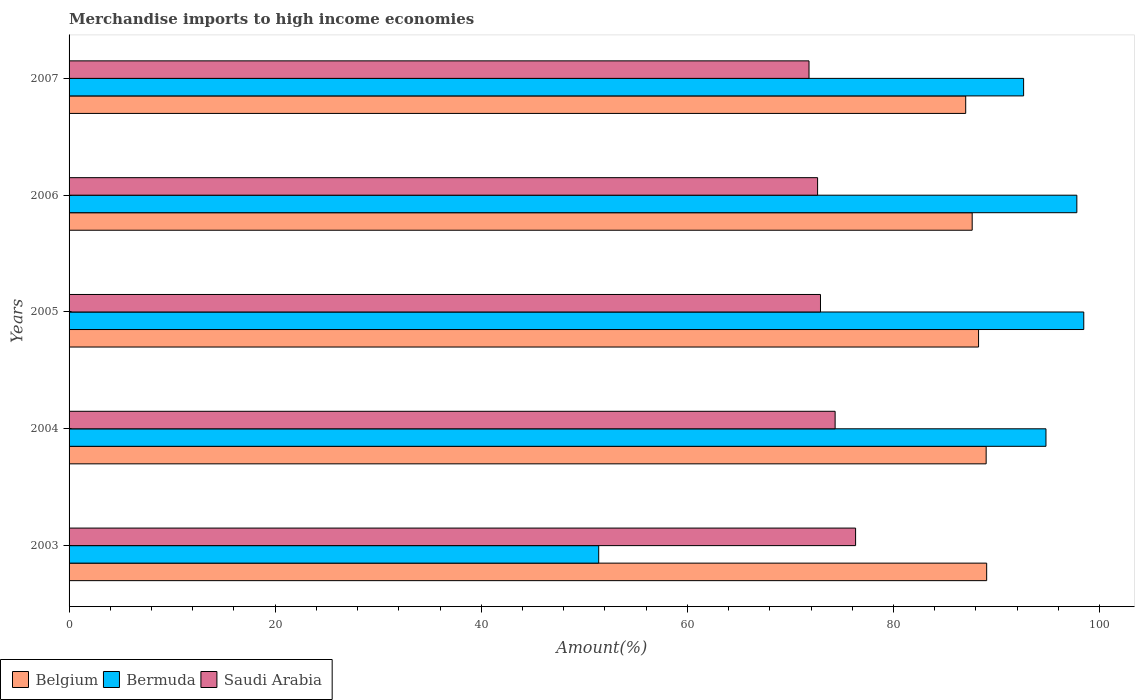How many groups of bars are there?
Provide a short and direct response. 5. Are the number of bars on each tick of the Y-axis equal?
Give a very brief answer. Yes. What is the label of the 1st group of bars from the top?
Your answer should be compact. 2007. In how many cases, is the number of bars for a given year not equal to the number of legend labels?
Make the answer very short. 0. What is the percentage of amount earned from merchandise imports in Saudi Arabia in 2005?
Ensure brevity in your answer.  72.91. Across all years, what is the maximum percentage of amount earned from merchandise imports in Saudi Arabia?
Make the answer very short. 76.32. Across all years, what is the minimum percentage of amount earned from merchandise imports in Saudi Arabia?
Offer a terse response. 71.8. In which year was the percentage of amount earned from merchandise imports in Belgium minimum?
Keep it short and to the point. 2007. What is the total percentage of amount earned from merchandise imports in Belgium in the graph?
Your answer should be compact. 440.92. What is the difference between the percentage of amount earned from merchandise imports in Saudi Arabia in 2005 and that in 2007?
Provide a succinct answer. 1.11. What is the difference between the percentage of amount earned from merchandise imports in Bermuda in 2004 and the percentage of amount earned from merchandise imports in Saudi Arabia in 2003?
Keep it short and to the point. 18.47. What is the average percentage of amount earned from merchandise imports in Belgium per year?
Offer a terse response. 88.18. In the year 2006, what is the difference between the percentage of amount earned from merchandise imports in Bermuda and percentage of amount earned from merchandise imports in Saudi Arabia?
Make the answer very short. 25.16. In how many years, is the percentage of amount earned from merchandise imports in Belgium greater than 48 %?
Your answer should be very brief. 5. What is the ratio of the percentage of amount earned from merchandise imports in Belgium in 2003 to that in 2004?
Provide a succinct answer. 1. Is the percentage of amount earned from merchandise imports in Belgium in 2005 less than that in 2006?
Provide a short and direct response. No. Is the difference between the percentage of amount earned from merchandise imports in Bermuda in 2003 and 2007 greater than the difference between the percentage of amount earned from merchandise imports in Saudi Arabia in 2003 and 2007?
Offer a very short reply. No. What is the difference between the highest and the second highest percentage of amount earned from merchandise imports in Belgium?
Ensure brevity in your answer.  0.05. What is the difference between the highest and the lowest percentage of amount earned from merchandise imports in Saudi Arabia?
Your answer should be compact. 4.52. In how many years, is the percentage of amount earned from merchandise imports in Bermuda greater than the average percentage of amount earned from merchandise imports in Bermuda taken over all years?
Provide a succinct answer. 4. Is the sum of the percentage of amount earned from merchandise imports in Bermuda in 2003 and 2005 greater than the maximum percentage of amount earned from merchandise imports in Belgium across all years?
Give a very brief answer. Yes. What does the 2nd bar from the top in 2006 represents?
Ensure brevity in your answer.  Bermuda. What does the 2nd bar from the bottom in 2003 represents?
Ensure brevity in your answer.  Bermuda. Are all the bars in the graph horizontal?
Offer a terse response. Yes. What is the difference between two consecutive major ticks on the X-axis?
Your response must be concise. 20. Are the values on the major ticks of X-axis written in scientific E-notation?
Provide a succinct answer. No. Where does the legend appear in the graph?
Ensure brevity in your answer.  Bottom left. How are the legend labels stacked?
Your response must be concise. Horizontal. What is the title of the graph?
Offer a terse response. Merchandise imports to high income economies. What is the label or title of the X-axis?
Offer a very short reply. Amount(%). What is the label or title of the Y-axis?
Offer a very short reply. Years. What is the Amount(%) in Belgium in 2003?
Give a very brief answer. 89.04. What is the Amount(%) of Bermuda in 2003?
Ensure brevity in your answer.  51.39. What is the Amount(%) in Saudi Arabia in 2003?
Your answer should be compact. 76.32. What is the Amount(%) in Belgium in 2004?
Provide a short and direct response. 88.99. What is the Amount(%) of Bermuda in 2004?
Offer a terse response. 94.79. What is the Amount(%) of Saudi Arabia in 2004?
Give a very brief answer. 74.33. What is the Amount(%) of Belgium in 2005?
Your response must be concise. 88.25. What is the Amount(%) in Bermuda in 2005?
Your answer should be very brief. 98.46. What is the Amount(%) in Saudi Arabia in 2005?
Ensure brevity in your answer.  72.91. What is the Amount(%) of Belgium in 2006?
Your answer should be compact. 87.63. What is the Amount(%) of Bermuda in 2006?
Ensure brevity in your answer.  97.79. What is the Amount(%) of Saudi Arabia in 2006?
Your answer should be very brief. 72.63. What is the Amount(%) of Belgium in 2007?
Make the answer very short. 87. What is the Amount(%) in Bermuda in 2007?
Your answer should be very brief. 92.62. What is the Amount(%) of Saudi Arabia in 2007?
Make the answer very short. 71.8. Across all years, what is the maximum Amount(%) of Belgium?
Provide a succinct answer. 89.04. Across all years, what is the maximum Amount(%) of Bermuda?
Offer a terse response. 98.46. Across all years, what is the maximum Amount(%) in Saudi Arabia?
Keep it short and to the point. 76.32. Across all years, what is the minimum Amount(%) of Belgium?
Ensure brevity in your answer.  87. Across all years, what is the minimum Amount(%) of Bermuda?
Ensure brevity in your answer.  51.39. Across all years, what is the minimum Amount(%) in Saudi Arabia?
Ensure brevity in your answer.  71.8. What is the total Amount(%) in Belgium in the graph?
Your response must be concise. 440.92. What is the total Amount(%) in Bermuda in the graph?
Keep it short and to the point. 435.05. What is the total Amount(%) in Saudi Arabia in the graph?
Make the answer very short. 368. What is the difference between the Amount(%) in Belgium in 2003 and that in 2004?
Your answer should be compact. 0.05. What is the difference between the Amount(%) in Bermuda in 2003 and that in 2004?
Keep it short and to the point. -43.4. What is the difference between the Amount(%) of Saudi Arabia in 2003 and that in 2004?
Your answer should be compact. 1.99. What is the difference between the Amount(%) of Belgium in 2003 and that in 2005?
Make the answer very short. 0.79. What is the difference between the Amount(%) of Bermuda in 2003 and that in 2005?
Your answer should be very brief. -47.07. What is the difference between the Amount(%) of Saudi Arabia in 2003 and that in 2005?
Your answer should be compact. 3.41. What is the difference between the Amount(%) in Belgium in 2003 and that in 2006?
Your response must be concise. 1.41. What is the difference between the Amount(%) of Bermuda in 2003 and that in 2006?
Give a very brief answer. -46.4. What is the difference between the Amount(%) in Saudi Arabia in 2003 and that in 2006?
Give a very brief answer. 3.69. What is the difference between the Amount(%) of Belgium in 2003 and that in 2007?
Give a very brief answer. 2.03. What is the difference between the Amount(%) in Bermuda in 2003 and that in 2007?
Ensure brevity in your answer.  -41.23. What is the difference between the Amount(%) in Saudi Arabia in 2003 and that in 2007?
Make the answer very short. 4.52. What is the difference between the Amount(%) of Belgium in 2004 and that in 2005?
Ensure brevity in your answer.  0.74. What is the difference between the Amount(%) in Bermuda in 2004 and that in 2005?
Make the answer very short. -3.67. What is the difference between the Amount(%) of Saudi Arabia in 2004 and that in 2005?
Make the answer very short. 1.42. What is the difference between the Amount(%) in Belgium in 2004 and that in 2006?
Your answer should be compact. 1.36. What is the difference between the Amount(%) in Bermuda in 2004 and that in 2006?
Your answer should be compact. -3. What is the difference between the Amount(%) in Saudi Arabia in 2004 and that in 2006?
Give a very brief answer. 1.7. What is the difference between the Amount(%) in Belgium in 2004 and that in 2007?
Give a very brief answer. 1.98. What is the difference between the Amount(%) of Bermuda in 2004 and that in 2007?
Provide a succinct answer. 2.17. What is the difference between the Amount(%) of Saudi Arabia in 2004 and that in 2007?
Offer a very short reply. 2.53. What is the difference between the Amount(%) in Belgium in 2005 and that in 2006?
Provide a short and direct response. 0.62. What is the difference between the Amount(%) of Bermuda in 2005 and that in 2006?
Offer a terse response. 0.67. What is the difference between the Amount(%) in Saudi Arabia in 2005 and that in 2006?
Your response must be concise. 0.28. What is the difference between the Amount(%) of Belgium in 2005 and that in 2007?
Provide a succinct answer. 1.25. What is the difference between the Amount(%) of Bermuda in 2005 and that in 2007?
Keep it short and to the point. 5.84. What is the difference between the Amount(%) of Saudi Arabia in 2005 and that in 2007?
Provide a short and direct response. 1.11. What is the difference between the Amount(%) in Belgium in 2006 and that in 2007?
Provide a succinct answer. 0.63. What is the difference between the Amount(%) of Bermuda in 2006 and that in 2007?
Your answer should be compact. 5.17. What is the difference between the Amount(%) of Saudi Arabia in 2006 and that in 2007?
Make the answer very short. 0.83. What is the difference between the Amount(%) in Belgium in 2003 and the Amount(%) in Bermuda in 2004?
Your answer should be very brief. -5.75. What is the difference between the Amount(%) of Belgium in 2003 and the Amount(%) of Saudi Arabia in 2004?
Ensure brevity in your answer.  14.7. What is the difference between the Amount(%) of Bermuda in 2003 and the Amount(%) of Saudi Arabia in 2004?
Offer a terse response. -22.94. What is the difference between the Amount(%) of Belgium in 2003 and the Amount(%) of Bermuda in 2005?
Provide a succinct answer. -9.42. What is the difference between the Amount(%) in Belgium in 2003 and the Amount(%) in Saudi Arabia in 2005?
Give a very brief answer. 16.13. What is the difference between the Amount(%) in Bermuda in 2003 and the Amount(%) in Saudi Arabia in 2005?
Your answer should be compact. -21.52. What is the difference between the Amount(%) of Belgium in 2003 and the Amount(%) of Bermuda in 2006?
Your answer should be very brief. -8.75. What is the difference between the Amount(%) in Belgium in 2003 and the Amount(%) in Saudi Arabia in 2006?
Offer a terse response. 16.41. What is the difference between the Amount(%) in Bermuda in 2003 and the Amount(%) in Saudi Arabia in 2006?
Provide a short and direct response. -21.24. What is the difference between the Amount(%) of Belgium in 2003 and the Amount(%) of Bermuda in 2007?
Your answer should be very brief. -3.58. What is the difference between the Amount(%) of Belgium in 2003 and the Amount(%) of Saudi Arabia in 2007?
Ensure brevity in your answer.  17.24. What is the difference between the Amount(%) of Bermuda in 2003 and the Amount(%) of Saudi Arabia in 2007?
Provide a succinct answer. -20.41. What is the difference between the Amount(%) of Belgium in 2004 and the Amount(%) of Bermuda in 2005?
Offer a terse response. -9.47. What is the difference between the Amount(%) of Belgium in 2004 and the Amount(%) of Saudi Arabia in 2005?
Give a very brief answer. 16.08. What is the difference between the Amount(%) of Bermuda in 2004 and the Amount(%) of Saudi Arabia in 2005?
Provide a succinct answer. 21.88. What is the difference between the Amount(%) in Belgium in 2004 and the Amount(%) in Bermuda in 2006?
Make the answer very short. -8.8. What is the difference between the Amount(%) in Belgium in 2004 and the Amount(%) in Saudi Arabia in 2006?
Your answer should be compact. 16.36. What is the difference between the Amount(%) of Bermuda in 2004 and the Amount(%) of Saudi Arabia in 2006?
Provide a short and direct response. 22.16. What is the difference between the Amount(%) in Belgium in 2004 and the Amount(%) in Bermuda in 2007?
Make the answer very short. -3.63. What is the difference between the Amount(%) of Belgium in 2004 and the Amount(%) of Saudi Arabia in 2007?
Keep it short and to the point. 17.19. What is the difference between the Amount(%) in Bermuda in 2004 and the Amount(%) in Saudi Arabia in 2007?
Provide a short and direct response. 22.99. What is the difference between the Amount(%) in Belgium in 2005 and the Amount(%) in Bermuda in 2006?
Keep it short and to the point. -9.54. What is the difference between the Amount(%) of Belgium in 2005 and the Amount(%) of Saudi Arabia in 2006?
Give a very brief answer. 15.62. What is the difference between the Amount(%) of Bermuda in 2005 and the Amount(%) of Saudi Arabia in 2006?
Offer a very short reply. 25.83. What is the difference between the Amount(%) of Belgium in 2005 and the Amount(%) of Bermuda in 2007?
Your answer should be very brief. -4.37. What is the difference between the Amount(%) of Belgium in 2005 and the Amount(%) of Saudi Arabia in 2007?
Ensure brevity in your answer.  16.45. What is the difference between the Amount(%) in Bermuda in 2005 and the Amount(%) in Saudi Arabia in 2007?
Ensure brevity in your answer.  26.66. What is the difference between the Amount(%) in Belgium in 2006 and the Amount(%) in Bermuda in 2007?
Keep it short and to the point. -4.99. What is the difference between the Amount(%) in Belgium in 2006 and the Amount(%) in Saudi Arabia in 2007?
Offer a very short reply. 15.83. What is the difference between the Amount(%) in Bermuda in 2006 and the Amount(%) in Saudi Arabia in 2007?
Ensure brevity in your answer.  25.99. What is the average Amount(%) in Belgium per year?
Provide a short and direct response. 88.18. What is the average Amount(%) in Bermuda per year?
Keep it short and to the point. 87.01. What is the average Amount(%) of Saudi Arabia per year?
Provide a succinct answer. 73.6. In the year 2003, what is the difference between the Amount(%) in Belgium and Amount(%) in Bermuda?
Give a very brief answer. 37.65. In the year 2003, what is the difference between the Amount(%) in Belgium and Amount(%) in Saudi Arabia?
Your answer should be compact. 12.72. In the year 2003, what is the difference between the Amount(%) of Bermuda and Amount(%) of Saudi Arabia?
Give a very brief answer. -24.93. In the year 2004, what is the difference between the Amount(%) in Belgium and Amount(%) in Bermuda?
Provide a succinct answer. -5.8. In the year 2004, what is the difference between the Amount(%) of Belgium and Amount(%) of Saudi Arabia?
Give a very brief answer. 14.66. In the year 2004, what is the difference between the Amount(%) in Bermuda and Amount(%) in Saudi Arabia?
Provide a short and direct response. 20.46. In the year 2005, what is the difference between the Amount(%) in Belgium and Amount(%) in Bermuda?
Offer a very short reply. -10.21. In the year 2005, what is the difference between the Amount(%) in Belgium and Amount(%) in Saudi Arabia?
Your answer should be compact. 15.34. In the year 2005, what is the difference between the Amount(%) in Bermuda and Amount(%) in Saudi Arabia?
Provide a short and direct response. 25.55. In the year 2006, what is the difference between the Amount(%) in Belgium and Amount(%) in Bermuda?
Provide a succinct answer. -10.15. In the year 2006, what is the difference between the Amount(%) in Belgium and Amount(%) in Saudi Arabia?
Make the answer very short. 15. In the year 2006, what is the difference between the Amount(%) of Bermuda and Amount(%) of Saudi Arabia?
Your response must be concise. 25.16. In the year 2007, what is the difference between the Amount(%) in Belgium and Amount(%) in Bermuda?
Your answer should be very brief. -5.62. In the year 2007, what is the difference between the Amount(%) in Belgium and Amount(%) in Saudi Arabia?
Ensure brevity in your answer.  15.2. In the year 2007, what is the difference between the Amount(%) in Bermuda and Amount(%) in Saudi Arabia?
Offer a very short reply. 20.82. What is the ratio of the Amount(%) in Bermuda in 2003 to that in 2004?
Offer a terse response. 0.54. What is the ratio of the Amount(%) of Saudi Arabia in 2003 to that in 2004?
Give a very brief answer. 1.03. What is the ratio of the Amount(%) of Belgium in 2003 to that in 2005?
Make the answer very short. 1.01. What is the ratio of the Amount(%) in Bermuda in 2003 to that in 2005?
Make the answer very short. 0.52. What is the ratio of the Amount(%) of Saudi Arabia in 2003 to that in 2005?
Provide a succinct answer. 1.05. What is the ratio of the Amount(%) in Bermuda in 2003 to that in 2006?
Keep it short and to the point. 0.53. What is the ratio of the Amount(%) in Saudi Arabia in 2003 to that in 2006?
Make the answer very short. 1.05. What is the ratio of the Amount(%) in Belgium in 2003 to that in 2007?
Ensure brevity in your answer.  1.02. What is the ratio of the Amount(%) in Bermuda in 2003 to that in 2007?
Ensure brevity in your answer.  0.55. What is the ratio of the Amount(%) of Saudi Arabia in 2003 to that in 2007?
Provide a succinct answer. 1.06. What is the ratio of the Amount(%) of Belgium in 2004 to that in 2005?
Offer a very short reply. 1.01. What is the ratio of the Amount(%) in Bermuda in 2004 to that in 2005?
Give a very brief answer. 0.96. What is the ratio of the Amount(%) in Saudi Arabia in 2004 to that in 2005?
Provide a short and direct response. 1.02. What is the ratio of the Amount(%) in Belgium in 2004 to that in 2006?
Make the answer very short. 1.02. What is the ratio of the Amount(%) of Bermuda in 2004 to that in 2006?
Offer a terse response. 0.97. What is the ratio of the Amount(%) of Saudi Arabia in 2004 to that in 2006?
Your answer should be very brief. 1.02. What is the ratio of the Amount(%) in Belgium in 2004 to that in 2007?
Ensure brevity in your answer.  1.02. What is the ratio of the Amount(%) of Bermuda in 2004 to that in 2007?
Offer a terse response. 1.02. What is the ratio of the Amount(%) in Saudi Arabia in 2004 to that in 2007?
Make the answer very short. 1.04. What is the ratio of the Amount(%) of Belgium in 2005 to that in 2006?
Give a very brief answer. 1.01. What is the ratio of the Amount(%) in Belgium in 2005 to that in 2007?
Offer a very short reply. 1.01. What is the ratio of the Amount(%) in Bermuda in 2005 to that in 2007?
Provide a succinct answer. 1.06. What is the ratio of the Amount(%) in Saudi Arabia in 2005 to that in 2007?
Your answer should be very brief. 1.02. What is the ratio of the Amount(%) of Bermuda in 2006 to that in 2007?
Keep it short and to the point. 1.06. What is the ratio of the Amount(%) in Saudi Arabia in 2006 to that in 2007?
Your response must be concise. 1.01. What is the difference between the highest and the second highest Amount(%) of Belgium?
Keep it short and to the point. 0.05. What is the difference between the highest and the second highest Amount(%) of Bermuda?
Offer a terse response. 0.67. What is the difference between the highest and the second highest Amount(%) of Saudi Arabia?
Offer a very short reply. 1.99. What is the difference between the highest and the lowest Amount(%) in Belgium?
Offer a terse response. 2.03. What is the difference between the highest and the lowest Amount(%) in Bermuda?
Offer a terse response. 47.07. What is the difference between the highest and the lowest Amount(%) of Saudi Arabia?
Ensure brevity in your answer.  4.52. 